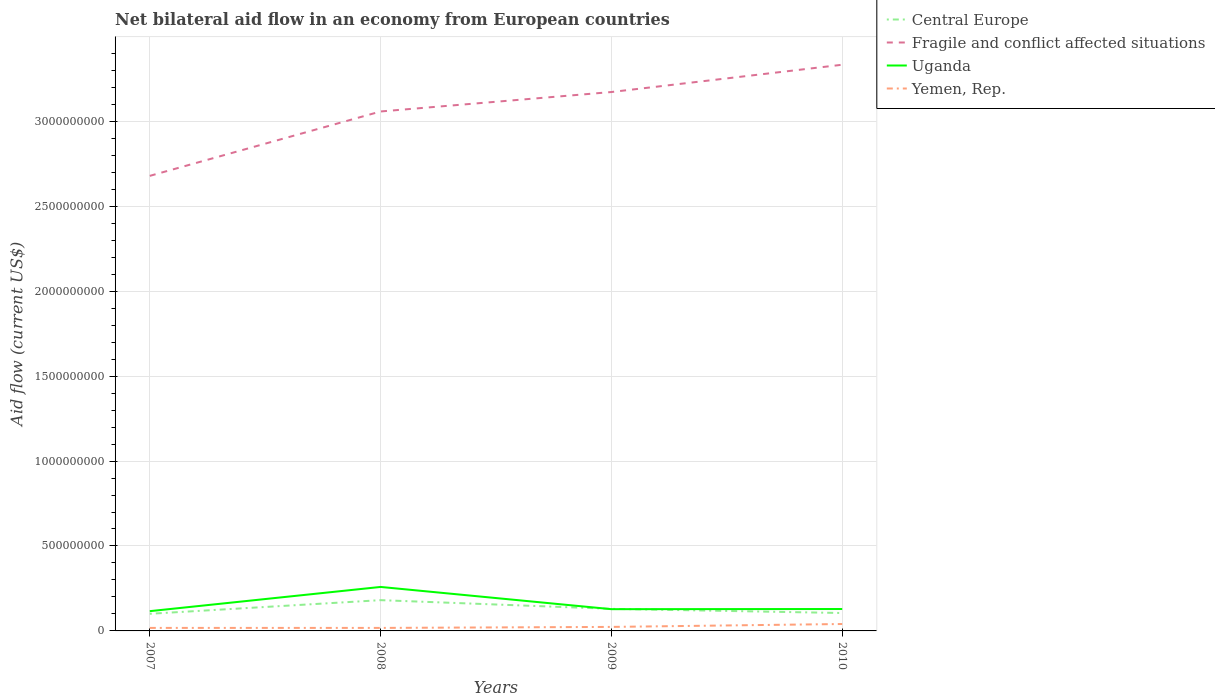Does the line corresponding to Central Europe intersect with the line corresponding to Fragile and conflict affected situations?
Provide a short and direct response. No. Across all years, what is the maximum net bilateral aid flow in Uganda?
Your response must be concise. 1.16e+08. In which year was the net bilateral aid flow in Yemen, Rep. maximum?
Your response must be concise. 2008. What is the total net bilateral aid flow in Central Europe in the graph?
Your answer should be compact. -4.52e+06. What is the difference between the highest and the second highest net bilateral aid flow in Uganda?
Ensure brevity in your answer.  1.43e+08. Is the net bilateral aid flow in Yemen, Rep. strictly greater than the net bilateral aid flow in Uganda over the years?
Ensure brevity in your answer.  Yes. Are the values on the major ticks of Y-axis written in scientific E-notation?
Provide a succinct answer. No. Does the graph contain any zero values?
Provide a short and direct response. No. Does the graph contain grids?
Offer a very short reply. Yes. Where does the legend appear in the graph?
Provide a short and direct response. Top right. How are the legend labels stacked?
Offer a very short reply. Vertical. What is the title of the graph?
Ensure brevity in your answer.  Net bilateral aid flow in an economy from European countries. What is the Aid flow (current US$) in Central Europe in 2007?
Keep it short and to the point. 1.01e+08. What is the Aid flow (current US$) of Fragile and conflict affected situations in 2007?
Offer a terse response. 2.68e+09. What is the Aid flow (current US$) in Uganda in 2007?
Keep it short and to the point. 1.16e+08. What is the Aid flow (current US$) of Yemen, Rep. in 2007?
Offer a terse response. 1.77e+07. What is the Aid flow (current US$) of Central Europe in 2008?
Provide a short and direct response. 1.81e+08. What is the Aid flow (current US$) in Fragile and conflict affected situations in 2008?
Give a very brief answer. 3.06e+09. What is the Aid flow (current US$) in Uganda in 2008?
Give a very brief answer. 2.59e+08. What is the Aid flow (current US$) of Yemen, Rep. in 2008?
Give a very brief answer. 1.77e+07. What is the Aid flow (current US$) of Central Europe in 2009?
Ensure brevity in your answer.  1.30e+08. What is the Aid flow (current US$) of Fragile and conflict affected situations in 2009?
Make the answer very short. 3.17e+09. What is the Aid flow (current US$) of Uganda in 2009?
Keep it short and to the point. 1.28e+08. What is the Aid flow (current US$) in Yemen, Rep. in 2009?
Ensure brevity in your answer.  2.36e+07. What is the Aid flow (current US$) in Central Europe in 2010?
Your response must be concise. 1.05e+08. What is the Aid flow (current US$) in Fragile and conflict affected situations in 2010?
Provide a short and direct response. 3.33e+09. What is the Aid flow (current US$) in Uganda in 2010?
Provide a succinct answer. 1.29e+08. What is the Aid flow (current US$) of Yemen, Rep. in 2010?
Offer a terse response. 4.07e+07. Across all years, what is the maximum Aid flow (current US$) of Central Europe?
Make the answer very short. 1.81e+08. Across all years, what is the maximum Aid flow (current US$) in Fragile and conflict affected situations?
Offer a very short reply. 3.33e+09. Across all years, what is the maximum Aid flow (current US$) in Uganda?
Offer a very short reply. 2.59e+08. Across all years, what is the maximum Aid flow (current US$) in Yemen, Rep.?
Provide a succinct answer. 4.07e+07. Across all years, what is the minimum Aid flow (current US$) of Central Europe?
Make the answer very short. 1.01e+08. Across all years, what is the minimum Aid flow (current US$) of Fragile and conflict affected situations?
Give a very brief answer. 2.68e+09. Across all years, what is the minimum Aid flow (current US$) in Uganda?
Your response must be concise. 1.16e+08. Across all years, what is the minimum Aid flow (current US$) in Yemen, Rep.?
Make the answer very short. 1.77e+07. What is the total Aid flow (current US$) in Central Europe in the graph?
Keep it short and to the point. 5.17e+08. What is the total Aid flow (current US$) in Fragile and conflict affected situations in the graph?
Your answer should be compact. 1.22e+1. What is the total Aid flow (current US$) in Uganda in the graph?
Your response must be concise. 6.32e+08. What is the total Aid flow (current US$) in Yemen, Rep. in the graph?
Your answer should be compact. 9.98e+07. What is the difference between the Aid flow (current US$) in Central Europe in 2007 and that in 2008?
Provide a succinct answer. -8.03e+07. What is the difference between the Aid flow (current US$) of Fragile and conflict affected situations in 2007 and that in 2008?
Provide a succinct answer. -3.79e+08. What is the difference between the Aid flow (current US$) of Uganda in 2007 and that in 2008?
Your response must be concise. -1.43e+08. What is the difference between the Aid flow (current US$) in Central Europe in 2007 and that in 2009?
Your response must be concise. -2.91e+07. What is the difference between the Aid flow (current US$) of Fragile and conflict affected situations in 2007 and that in 2009?
Your answer should be very brief. -4.93e+08. What is the difference between the Aid flow (current US$) in Uganda in 2007 and that in 2009?
Your response must be concise. -1.17e+07. What is the difference between the Aid flow (current US$) of Yemen, Rep. in 2007 and that in 2009?
Your response must be concise. -5.86e+06. What is the difference between the Aid flow (current US$) in Central Europe in 2007 and that in 2010?
Your answer should be very brief. -4.52e+06. What is the difference between the Aid flow (current US$) in Fragile and conflict affected situations in 2007 and that in 2010?
Your response must be concise. -6.54e+08. What is the difference between the Aid flow (current US$) of Uganda in 2007 and that in 2010?
Provide a short and direct response. -1.26e+07. What is the difference between the Aid flow (current US$) in Yemen, Rep. in 2007 and that in 2010?
Provide a succinct answer. -2.30e+07. What is the difference between the Aid flow (current US$) of Central Europe in 2008 and that in 2009?
Your response must be concise. 5.12e+07. What is the difference between the Aid flow (current US$) of Fragile and conflict affected situations in 2008 and that in 2009?
Make the answer very short. -1.14e+08. What is the difference between the Aid flow (current US$) in Uganda in 2008 and that in 2009?
Provide a short and direct response. 1.31e+08. What is the difference between the Aid flow (current US$) of Yemen, Rep. in 2008 and that in 2009?
Make the answer very short. -5.90e+06. What is the difference between the Aid flow (current US$) in Central Europe in 2008 and that in 2010?
Give a very brief answer. 7.57e+07. What is the difference between the Aid flow (current US$) of Fragile and conflict affected situations in 2008 and that in 2010?
Keep it short and to the point. -2.75e+08. What is the difference between the Aid flow (current US$) of Uganda in 2008 and that in 2010?
Make the answer very short. 1.30e+08. What is the difference between the Aid flow (current US$) of Yemen, Rep. in 2008 and that in 2010?
Make the answer very short. -2.30e+07. What is the difference between the Aid flow (current US$) in Central Europe in 2009 and that in 2010?
Provide a succinct answer. 2.46e+07. What is the difference between the Aid flow (current US$) in Fragile and conflict affected situations in 2009 and that in 2010?
Make the answer very short. -1.61e+08. What is the difference between the Aid flow (current US$) of Uganda in 2009 and that in 2010?
Your answer should be very brief. -9.00e+05. What is the difference between the Aid flow (current US$) in Yemen, Rep. in 2009 and that in 2010?
Make the answer very short. -1.71e+07. What is the difference between the Aid flow (current US$) in Central Europe in 2007 and the Aid flow (current US$) in Fragile and conflict affected situations in 2008?
Provide a succinct answer. -2.96e+09. What is the difference between the Aid flow (current US$) in Central Europe in 2007 and the Aid flow (current US$) in Uganda in 2008?
Keep it short and to the point. -1.58e+08. What is the difference between the Aid flow (current US$) in Central Europe in 2007 and the Aid flow (current US$) in Yemen, Rep. in 2008?
Give a very brief answer. 8.32e+07. What is the difference between the Aid flow (current US$) of Fragile and conflict affected situations in 2007 and the Aid flow (current US$) of Uganda in 2008?
Your answer should be very brief. 2.42e+09. What is the difference between the Aid flow (current US$) of Fragile and conflict affected situations in 2007 and the Aid flow (current US$) of Yemen, Rep. in 2008?
Keep it short and to the point. 2.66e+09. What is the difference between the Aid flow (current US$) in Uganda in 2007 and the Aid flow (current US$) in Yemen, Rep. in 2008?
Provide a succinct answer. 9.86e+07. What is the difference between the Aid flow (current US$) of Central Europe in 2007 and the Aid flow (current US$) of Fragile and conflict affected situations in 2009?
Give a very brief answer. -3.07e+09. What is the difference between the Aid flow (current US$) of Central Europe in 2007 and the Aid flow (current US$) of Uganda in 2009?
Your answer should be compact. -2.72e+07. What is the difference between the Aid flow (current US$) of Central Europe in 2007 and the Aid flow (current US$) of Yemen, Rep. in 2009?
Ensure brevity in your answer.  7.73e+07. What is the difference between the Aid flow (current US$) of Fragile and conflict affected situations in 2007 and the Aid flow (current US$) of Uganda in 2009?
Make the answer very short. 2.55e+09. What is the difference between the Aid flow (current US$) in Fragile and conflict affected situations in 2007 and the Aid flow (current US$) in Yemen, Rep. in 2009?
Offer a terse response. 2.66e+09. What is the difference between the Aid flow (current US$) in Uganda in 2007 and the Aid flow (current US$) in Yemen, Rep. in 2009?
Make the answer very short. 9.28e+07. What is the difference between the Aid flow (current US$) in Central Europe in 2007 and the Aid flow (current US$) in Fragile and conflict affected situations in 2010?
Your answer should be compact. -3.23e+09. What is the difference between the Aid flow (current US$) in Central Europe in 2007 and the Aid flow (current US$) in Uganda in 2010?
Offer a terse response. -2.81e+07. What is the difference between the Aid flow (current US$) of Central Europe in 2007 and the Aid flow (current US$) of Yemen, Rep. in 2010?
Your answer should be compact. 6.01e+07. What is the difference between the Aid flow (current US$) of Fragile and conflict affected situations in 2007 and the Aid flow (current US$) of Uganda in 2010?
Your answer should be compact. 2.55e+09. What is the difference between the Aid flow (current US$) of Fragile and conflict affected situations in 2007 and the Aid flow (current US$) of Yemen, Rep. in 2010?
Offer a very short reply. 2.64e+09. What is the difference between the Aid flow (current US$) in Uganda in 2007 and the Aid flow (current US$) in Yemen, Rep. in 2010?
Offer a terse response. 7.56e+07. What is the difference between the Aid flow (current US$) of Central Europe in 2008 and the Aid flow (current US$) of Fragile and conflict affected situations in 2009?
Your answer should be compact. -2.99e+09. What is the difference between the Aid flow (current US$) in Central Europe in 2008 and the Aid flow (current US$) in Uganda in 2009?
Provide a succinct answer. 5.31e+07. What is the difference between the Aid flow (current US$) of Central Europe in 2008 and the Aid flow (current US$) of Yemen, Rep. in 2009?
Provide a short and direct response. 1.58e+08. What is the difference between the Aid flow (current US$) of Fragile and conflict affected situations in 2008 and the Aid flow (current US$) of Uganda in 2009?
Provide a succinct answer. 2.93e+09. What is the difference between the Aid flow (current US$) in Fragile and conflict affected situations in 2008 and the Aid flow (current US$) in Yemen, Rep. in 2009?
Ensure brevity in your answer.  3.03e+09. What is the difference between the Aid flow (current US$) in Uganda in 2008 and the Aid flow (current US$) in Yemen, Rep. in 2009?
Your response must be concise. 2.35e+08. What is the difference between the Aid flow (current US$) of Central Europe in 2008 and the Aid flow (current US$) of Fragile and conflict affected situations in 2010?
Your answer should be compact. -3.15e+09. What is the difference between the Aid flow (current US$) of Central Europe in 2008 and the Aid flow (current US$) of Uganda in 2010?
Provide a succinct answer. 5.22e+07. What is the difference between the Aid flow (current US$) in Central Europe in 2008 and the Aid flow (current US$) in Yemen, Rep. in 2010?
Keep it short and to the point. 1.40e+08. What is the difference between the Aid flow (current US$) in Fragile and conflict affected situations in 2008 and the Aid flow (current US$) in Uganda in 2010?
Give a very brief answer. 2.93e+09. What is the difference between the Aid flow (current US$) in Fragile and conflict affected situations in 2008 and the Aid flow (current US$) in Yemen, Rep. in 2010?
Keep it short and to the point. 3.02e+09. What is the difference between the Aid flow (current US$) of Uganda in 2008 and the Aid flow (current US$) of Yemen, Rep. in 2010?
Your response must be concise. 2.18e+08. What is the difference between the Aid flow (current US$) in Central Europe in 2009 and the Aid flow (current US$) in Fragile and conflict affected situations in 2010?
Provide a succinct answer. -3.20e+09. What is the difference between the Aid flow (current US$) of Central Europe in 2009 and the Aid flow (current US$) of Yemen, Rep. in 2010?
Give a very brief answer. 8.92e+07. What is the difference between the Aid flow (current US$) in Fragile and conflict affected situations in 2009 and the Aid flow (current US$) in Uganda in 2010?
Your answer should be very brief. 3.04e+09. What is the difference between the Aid flow (current US$) in Fragile and conflict affected situations in 2009 and the Aid flow (current US$) in Yemen, Rep. in 2010?
Your answer should be compact. 3.13e+09. What is the difference between the Aid flow (current US$) of Uganda in 2009 and the Aid flow (current US$) of Yemen, Rep. in 2010?
Keep it short and to the point. 8.73e+07. What is the average Aid flow (current US$) of Central Europe per year?
Make the answer very short. 1.29e+08. What is the average Aid flow (current US$) of Fragile and conflict affected situations per year?
Make the answer very short. 3.06e+09. What is the average Aid flow (current US$) of Uganda per year?
Keep it short and to the point. 1.58e+08. What is the average Aid flow (current US$) of Yemen, Rep. per year?
Offer a very short reply. 2.49e+07. In the year 2007, what is the difference between the Aid flow (current US$) in Central Europe and Aid flow (current US$) in Fragile and conflict affected situations?
Make the answer very short. -2.58e+09. In the year 2007, what is the difference between the Aid flow (current US$) in Central Europe and Aid flow (current US$) in Uganda?
Your answer should be compact. -1.55e+07. In the year 2007, what is the difference between the Aid flow (current US$) of Central Europe and Aid flow (current US$) of Yemen, Rep.?
Your response must be concise. 8.31e+07. In the year 2007, what is the difference between the Aid flow (current US$) in Fragile and conflict affected situations and Aid flow (current US$) in Uganda?
Your answer should be compact. 2.56e+09. In the year 2007, what is the difference between the Aid flow (current US$) of Fragile and conflict affected situations and Aid flow (current US$) of Yemen, Rep.?
Provide a succinct answer. 2.66e+09. In the year 2007, what is the difference between the Aid flow (current US$) in Uganda and Aid flow (current US$) in Yemen, Rep.?
Your answer should be compact. 9.86e+07. In the year 2008, what is the difference between the Aid flow (current US$) in Central Europe and Aid flow (current US$) in Fragile and conflict affected situations?
Offer a very short reply. -2.88e+09. In the year 2008, what is the difference between the Aid flow (current US$) of Central Europe and Aid flow (current US$) of Uganda?
Give a very brief answer. -7.78e+07. In the year 2008, what is the difference between the Aid flow (current US$) of Central Europe and Aid flow (current US$) of Yemen, Rep.?
Offer a terse response. 1.63e+08. In the year 2008, what is the difference between the Aid flow (current US$) of Fragile and conflict affected situations and Aid flow (current US$) of Uganda?
Make the answer very short. 2.80e+09. In the year 2008, what is the difference between the Aid flow (current US$) in Fragile and conflict affected situations and Aid flow (current US$) in Yemen, Rep.?
Provide a short and direct response. 3.04e+09. In the year 2008, what is the difference between the Aid flow (current US$) of Uganda and Aid flow (current US$) of Yemen, Rep.?
Give a very brief answer. 2.41e+08. In the year 2009, what is the difference between the Aid flow (current US$) in Central Europe and Aid flow (current US$) in Fragile and conflict affected situations?
Ensure brevity in your answer.  -3.04e+09. In the year 2009, what is the difference between the Aid flow (current US$) in Central Europe and Aid flow (current US$) in Uganda?
Provide a succinct answer. 1.90e+06. In the year 2009, what is the difference between the Aid flow (current US$) of Central Europe and Aid flow (current US$) of Yemen, Rep.?
Your answer should be compact. 1.06e+08. In the year 2009, what is the difference between the Aid flow (current US$) of Fragile and conflict affected situations and Aid flow (current US$) of Uganda?
Provide a short and direct response. 3.04e+09. In the year 2009, what is the difference between the Aid flow (current US$) of Fragile and conflict affected situations and Aid flow (current US$) of Yemen, Rep.?
Make the answer very short. 3.15e+09. In the year 2009, what is the difference between the Aid flow (current US$) in Uganda and Aid flow (current US$) in Yemen, Rep.?
Provide a short and direct response. 1.04e+08. In the year 2010, what is the difference between the Aid flow (current US$) in Central Europe and Aid flow (current US$) in Fragile and conflict affected situations?
Make the answer very short. -3.23e+09. In the year 2010, what is the difference between the Aid flow (current US$) of Central Europe and Aid flow (current US$) of Uganda?
Make the answer very short. -2.36e+07. In the year 2010, what is the difference between the Aid flow (current US$) in Central Europe and Aid flow (current US$) in Yemen, Rep.?
Offer a very short reply. 6.47e+07. In the year 2010, what is the difference between the Aid flow (current US$) of Fragile and conflict affected situations and Aid flow (current US$) of Uganda?
Ensure brevity in your answer.  3.20e+09. In the year 2010, what is the difference between the Aid flow (current US$) of Fragile and conflict affected situations and Aid flow (current US$) of Yemen, Rep.?
Provide a succinct answer. 3.29e+09. In the year 2010, what is the difference between the Aid flow (current US$) of Uganda and Aid flow (current US$) of Yemen, Rep.?
Your response must be concise. 8.82e+07. What is the ratio of the Aid flow (current US$) in Central Europe in 2007 to that in 2008?
Ensure brevity in your answer.  0.56. What is the ratio of the Aid flow (current US$) of Fragile and conflict affected situations in 2007 to that in 2008?
Provide a succinct answer. 0.88. What is the ratio of the Aid flow (current US$) in Uganda in 2007 to that in 2008?
Offer a terse response. 0.45. What is the ratio of the Aid flow (current US$) in Central Europe in 2007 to that in 2009?
Make the answer very short. 0.78. What is the ratio of the Aid flow (current US$) in Fragile and conflict affected situations in 2007 to that in 2009?
Provide a short and direct response. 0.84. What is the ratio of the Aid flow (current US$) of Uganda in 2007 to that in 2009?
Your answer should be very brief. 0.91. What is the ratio of the Aid flow (current US$) in Yemen, Rep. in 2007 to that in 2009?
Offer a terse response. 0.75. What is the ratio of the Aid flow (current US$) in Central Europe in 2007 to that in 2010?
Ensure brevity in your answer.  0.96. What is the ratio of the Aid flow (current US$) of Fragile and conflict affected situations in 2007 to that in 2010?
Offer a very short reply. 0.8. What is the ratio of the Aid flow (current US$) in Uganda in 2007 to that in 2010?
Your response must be concise. 0.9. What is the ratio of the Aid flow (current US$) in Yemen, Rep. in 2007 to that in 2010?
Give a very brief answer. 0.44. What is the ratio of the Aid flow (current US$) in Central Europe in 2008 to that in 2009?
Offer a terse response. 1.39. What is the ratio of the Aid flow (current US$) of Fragile and conflict affected situations in 2008 to that in 2009?
Your response must be concise. 0.96. What is the ratio of the Aid flow (current US$) in Uganda in 2008 to that in 2009?
Make the answer very short. 2.02. What is the ratio of the Aid flow (current US$) of Central Europe in 2008 to that in 2010?
Keep it short and to the point. 1.72. What is the ratio of the Aid flow (current US$) of Fragile and conflict affected situations in 2008 to that in 2010?
Make the answer very short. 0.92. What is the ratio of the Aid flow (current US$) in Uganda in 2008 to that in 2010?
Make the answer very short. 2.01. What is the ratio of the Aid flow (current US$) in Yemen, Rep. in 2008 to that in 2010?
Offer a terse response. 0.43. What is the ratio of the Aid flow (current US$) in Central Europe in 2009 to that in 2010?
Offer a terse response. 1.23. What is the ratio of the Aid flow (current US$) in Fragile and conflict affected situations in 2009 to that in 2010?
Provide a succinct answer. 0.95. What is the ratio of the Aid flow (current US$) in Yemen, Rep. in 2009 to that in 2010?
Offer a very short reply. 0.58. What is the difference between the highest and the second highest Aid flow (current US$) in Central Europe?
Offer a very short reply. 5.12e+07. What is the difference between the highest and the second highest Aid flow (current US$) in Fragile and conflict affected situations?
Give a very brief answer. 1.61e+08. What is the difference between the highest and the second highest Aid flow (current US$) in Uganda?
Offer a very short reply. 1.30e+08. What is the difference between the highest and the second highest Aid flow (current US$) in Yemen, Rep.?
Make the answer very short. 1.71e+07. What is the difference between the highest and the lowest Aid flow (current US$) in Central Europe?
Your answer should be very brief. 8.03e+07. What is the difference between the highest and the lowest Aid flow (current US$) of Fragile and conflict affected situations?
Give a very brief answer. 6.54e+08. What is the difference between the highest and the lowest Aid flow (current US$) of Uganda?
Make the answer very short. 1.43e+08. What is the difference between the highest and the lowest Aid flow (current US$) of Yemen, Rep.?
Give a very brief answer. 2.30e+07. 